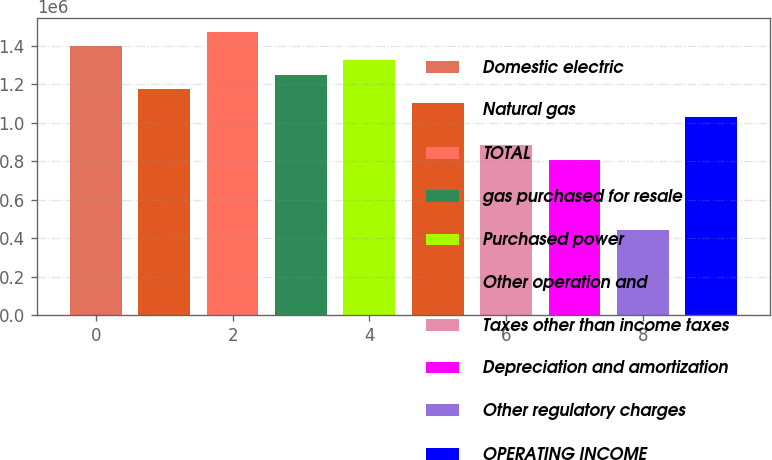<chart> <loc_0><loc_0><loc_500><loc_500><bar_chart><fcel>Domestic electric<fcel>Natural gas<fcel>TOTAL<fcel>gas purchased for resale<fcel>Purchased power<fcel>Other operation and<fcel>Taxes other than income taxes<fcel>Depreciation and amortization<fcel>Other regulatory charges<fcel>OPERATING INCOME<nl><fcel>1.39791e+06<fcel>1.17723e+06<fcel>1.47147e+06<fcel>1.25079e+06<fcel>1.32435e+06<fcel>1.10367e+06<fcel>882988<fcel>809428<fcel>441629<fcel>1.03011e+06<nl></chart> 